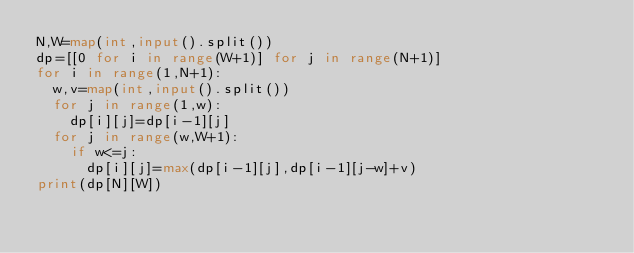<code> <loc_0><loc_0><loc_500><loc_500><_Python_>N,W=map(int,input().split())
dp=[[0 for i in range(W+1)] for j in range(N+1)]
for i in range(1,N+1):
  w,v=map(int,input().split())
  for j in range(1,w):
    dp[i][j]=dp[i-1][j]
  for j in range(w,W+1):
    if w<=j:
      dp[i][j]=max(dp[i-1][j],dp[i-1][j-w]+v)
print(dp[N][W])</code> 